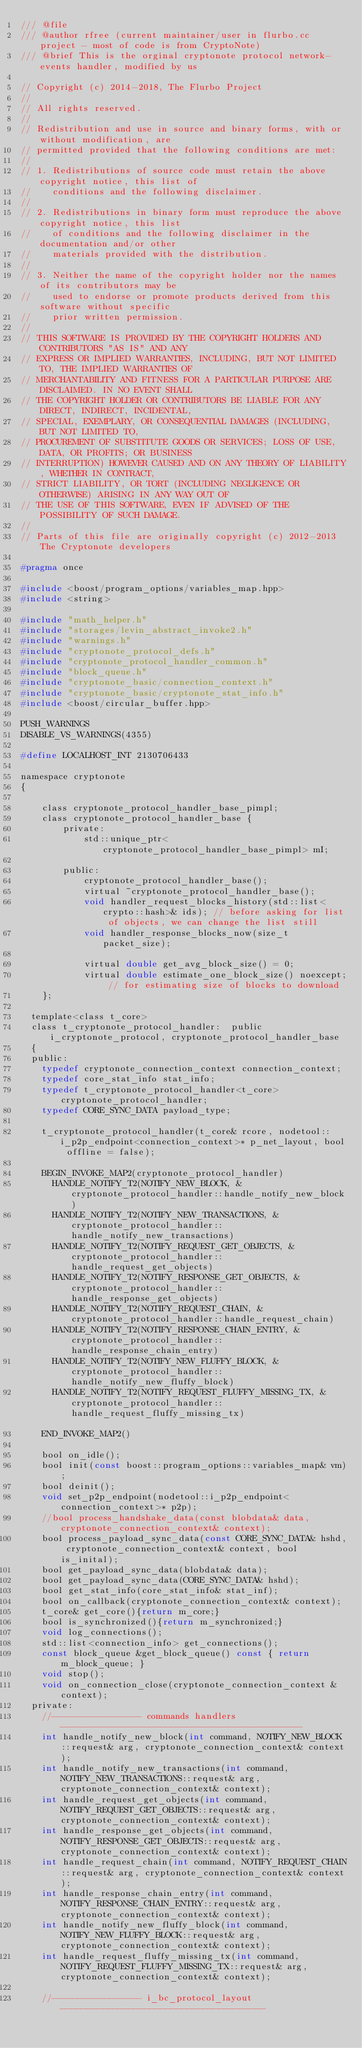<code> <loc_0><loc_0><loc_500><loc_500><_C_>/// @file
/// @author rfree (current maintainer/user in flurbo.cc project - most of code is from CryptoNote)
/// @brief This is the orginal cryptonote protocol network-events handler, modified by us

// Copyright (c) 2014-2018, The Flurbo Project
// 
// All rights reserved.
// 
// Redistribution and use in source and binary forms, with or without modification, are
// permitted provided that the following conditions are met:
// 
// 1. Redistributions of source code must retain the above copyright notice, this list of
//    conditions and the following disclaimer.
// 
// 2. Redistributions in binary form must reproduce the above copyright notice, this list
//    of conditions and the following disclaimer in the documentation and/or other
//    materials provided with the distribution.
// 
// 3. Neither the name of the copyright holder nor the names of its contributors may be
//    used to endorse or promote products derived from this software without specific
//    prior written permission.
// 
// THIS SOFTWARE IS PROVIDED BY THE COPYRIGHT HOLDERS AND CONTRIBUTORS "AS IS" AND ANY
// EXPRESS OR IMPLIED WARRANTIES, INCLUDING, BUT NOT LIMITED TO, THE IMPLIED WARRANTIES OF
// MERCHANTABILITY AND FITNESS FOR A PARTICULAR PURPOSE ARE DISCLAIMED. IN NO EVENT SHALL
// THE COPYRIGHT HOLDER OR CONTRIBUTORS BE LIABLE FOR ANY DIRECT, INDIRECT, INCIDENTAL,
// SPECIAL, EXEMPLARY, OR CONSEQUENTIAL DAMAGES (INCLUDING, BUT NOT LIMITED TO,
// PROCUREMENT OF SUBSTITUTE GOODS OR SERVICES; LOSS OF USE, DATA, OR PROFITS; OR BUSINESS
// INTERRUPTION) HOWEVER CAUSED AND ON ANY THEORY OF LIABILITY, WHETHER IN CONTRACT,
// STRICT LIABILITY, OR TORT (INCLUDING NEGLIGENCE OR OTHERWISE) ARISING IN ANY WAY OUT OF
// THE USE OF THIS SOFTWARE, EVEN IF ADVISED OF THE POSSIBILITY OF SUCH DAMAGE.
// 
// Parts of this file are originally copyright (c) 2012-2013 The Cryptonote developers

#pragma once

#include <boost/program_options/variables_map.hpp>
#include <string>

#include "math_helper.h"
#include "storages/levin_abstract_invoke2.h"
#include "warnings.h"
#include "cryptonote_protocol_defs.h"
#include "cryptonote_protocol_handler_common.h"
#include "block_queue.h"
#include "cryptonote_basic/connection_context.h"
#include "cryptonote_basic/cryptonote_stat_info.h"
#include <boost/circular_buffer.hpp>

PUSH_WARNINGS
DISABLE_VS_WARNINGS(4355)

#define LOCALHOST_INT 2130706433

namespace cryptonote
{

	class cryptonote_protocol_handler_base_pimpl;
	class cryptonote_protocol_handler_base {
		private:
			std::unique_ptr<cryptonote_protocol_handler_base_pimpl> mI;

		public:
			cryptonote_protocol_handler_base();
			virtual ~cryptonote_protocol_handler_base();
			void handler_request_blocks_history(std::list<crypto::hash>& ids); // before asking for list of objects, we can change the list still
			void handler_response_blocks_now(size_t packet_size);
			
			virtual double get_avg_block_size() = 0;
			virtual double estimate_one_block_size() noexcept; // for estimating size of blocks to download
	};

  template<class t_core>
  class t_cryptonote_protocol_handler:  public i_cryptonote_protocol, cryptonote_protocol_handler_base
  { 
  public:
    typedef cryptonote_connection_context connection_context;
    typedef core_stat_info stat_info;
    typedef t_cryptonote_protocol_handler<t_core> cryptonote_protocol_handler;
    typedef CORE_SYNC_DATA payload_type;

    t_cryptonote_protocol_handler(t_core& rcore, nodetool::i_p2p_endpoint<connection_context>* p_net_layout, bool offline = false);

    BEGIN_INVOKE_MAP2(cryptonote_protocol_handler)
      HANDLE_NOTIFY_T2(NOTIFY_NEW_BLOCK, &cryptonote_protocol_handler::handle_notify_new_block)
      HANDLE_NOTIFY_T2(NOTIFY_NEW_TRANSACTIONS, &cryptonote_protocol_handler::handle_notify_new_transactions)
      HANDLE_NOTIFY_T2(NOTIFY_REQUEST_GET_OBJECTS, &cryptonote_protocol_handler::handle_request_get_objects)
      HANDLE_NOTIFY_T2(NOTIFY_RESPONSE_GET_OBJECTS, &cryptonote_protocol_handler::handle_response_get_objects)
      HANDLE_NOTIFY_T2(NOTIFY_REQUEST_CHAIN, &cryptonote_protocol_handler::handle_request_chain)
      HANDLE_NOTIFY_T2(NOTIFY_RESPONSE_CHAIN_ENTRY, &cryptonote_protocol_handler::handle_response_chain_entry)
      HANDLE_NOTIFY_T2(NOTIFY_NEW_FLUFFY_BLOCK, &cryptonote_protocol_handler::handle_notify_new_fluffy_block)			
      HANDLE_NOTIFY_T2(NOTIFY_REQUEST_FLUFFY_MISSING_TX, &cryptonote_protocol_handler::handle_request_fluffy_missing_tx)						
    END_INVOKE_MAP2()

    bool on_idle();
    bool init(const boost::program_options::variables_map& vm);
    bool deinit();
    void set_p2p_endpoint(nodetool::i_p2p_endpoint<connection_context>* p2p);
    //bool process_handshake_data(const blobdata& data, cryptonote_connection_context& context);
    bool process_payload_sync_data(const CORE_SYNC_DATA& hshd, cryptonote_connection_context& context, bool is_inital);
    bool get_payload_sync_data(blobdata& data);
    bool get_payload_sync_data(CORE_SYNC_DATA& hshd);
    bool get_stat_info(core_stat_info& stat_inf);
    bool on_callback(cryptonote_connection_context& context);
    t_core& get_core(){return m_core;}
    bool is_synchronized(){return m_synchronized;}
    void log_connections();
    std::list<connection_info> get_connections();
    const block_queue &get_block_queue() const { return m_block_queue; }
    void stop();
    void on_connection_close(cryptonote_connection_context &context);
  private:
    //----------------- commands handlers ----------------------------------------------
    int handle_notify_new_block(int command, NOTIFY_NEW_BLOCK::request& arg, cryptonote_connection_context& context);
    int handle_notify_new_transactions(int command, NOTIFY_NEW_TRANSACTIONS::request& arg, cryptonote_connection_context& context);
    int handle_request_get_objects(int command, NOTIFY_REQUEST_GET_OBJECTS::request& arg, cryptonote_connection_context& context);
    int handle_response_get_objects(int command, NOTIFY_RESPONSE_GET_OBJECTS::request& arg, cryptonote_connection_context& context);
    int handle_request_chain(int command, NOTIFY_REQUEST_CHAIN::request& arg, cryptonote_connection_context& context);
    int handle_response_chain_entry(int command, NOTIFY_RESPONSE_CHAIN_ENTRY::request& arg, cryptonote_connection_context& context);
    int handle_notify_new_fluffy_block(int command, NOTIFY_NEW_FLUFFY_BLOCK::request& arg, cryptonote_connection_context& context);
    int handle_request_fluffy_missing_tx(int command, NOTIFY_REQUEST_FLUFFY_MISSING_TX::request& arg, cryptonote_connection_context& context);
		
    //----------------- i_bc_protocol_layout ---------------------------------------</code> 